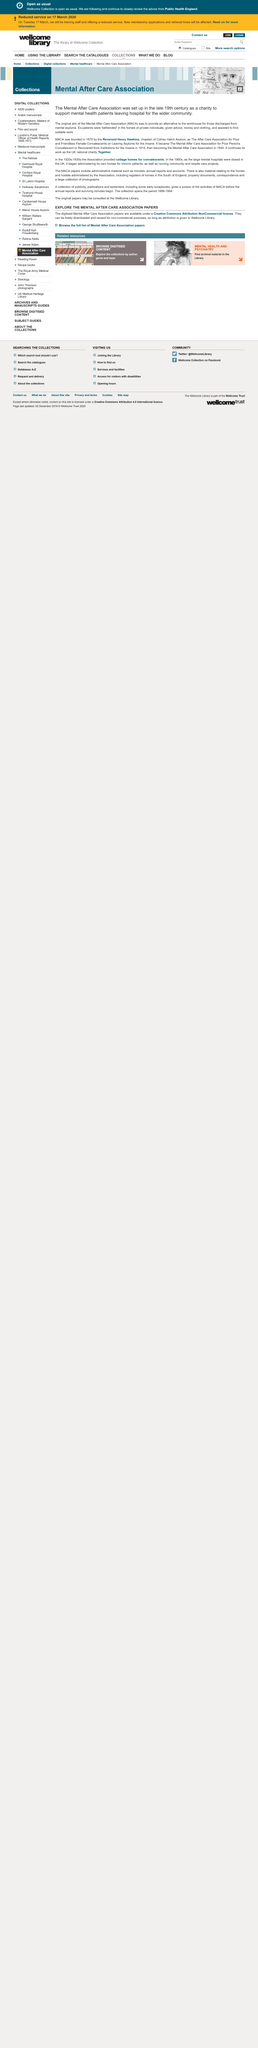Mention a couple of crucial points in this snapshot. MACA, formerly known as the MACA, continues its mission as the UK national charity known as Together. MACA was established by the Reverend Henry Hawkins, chaplain of Conley Hatch Asylum, in its early stages. The Mental After Care Association was established in the late 19th century. 